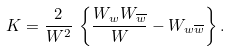Convert formula to latex. <formula><loc_0><loc_0><loc_500><loc_500>K = \frac { 2 } { W ^ { 2 } } \, \left \{ \frac { W _ { w } W _ { \overline { w } } } { W } - W _ { w \overline { w } } \right \} .</formula> 